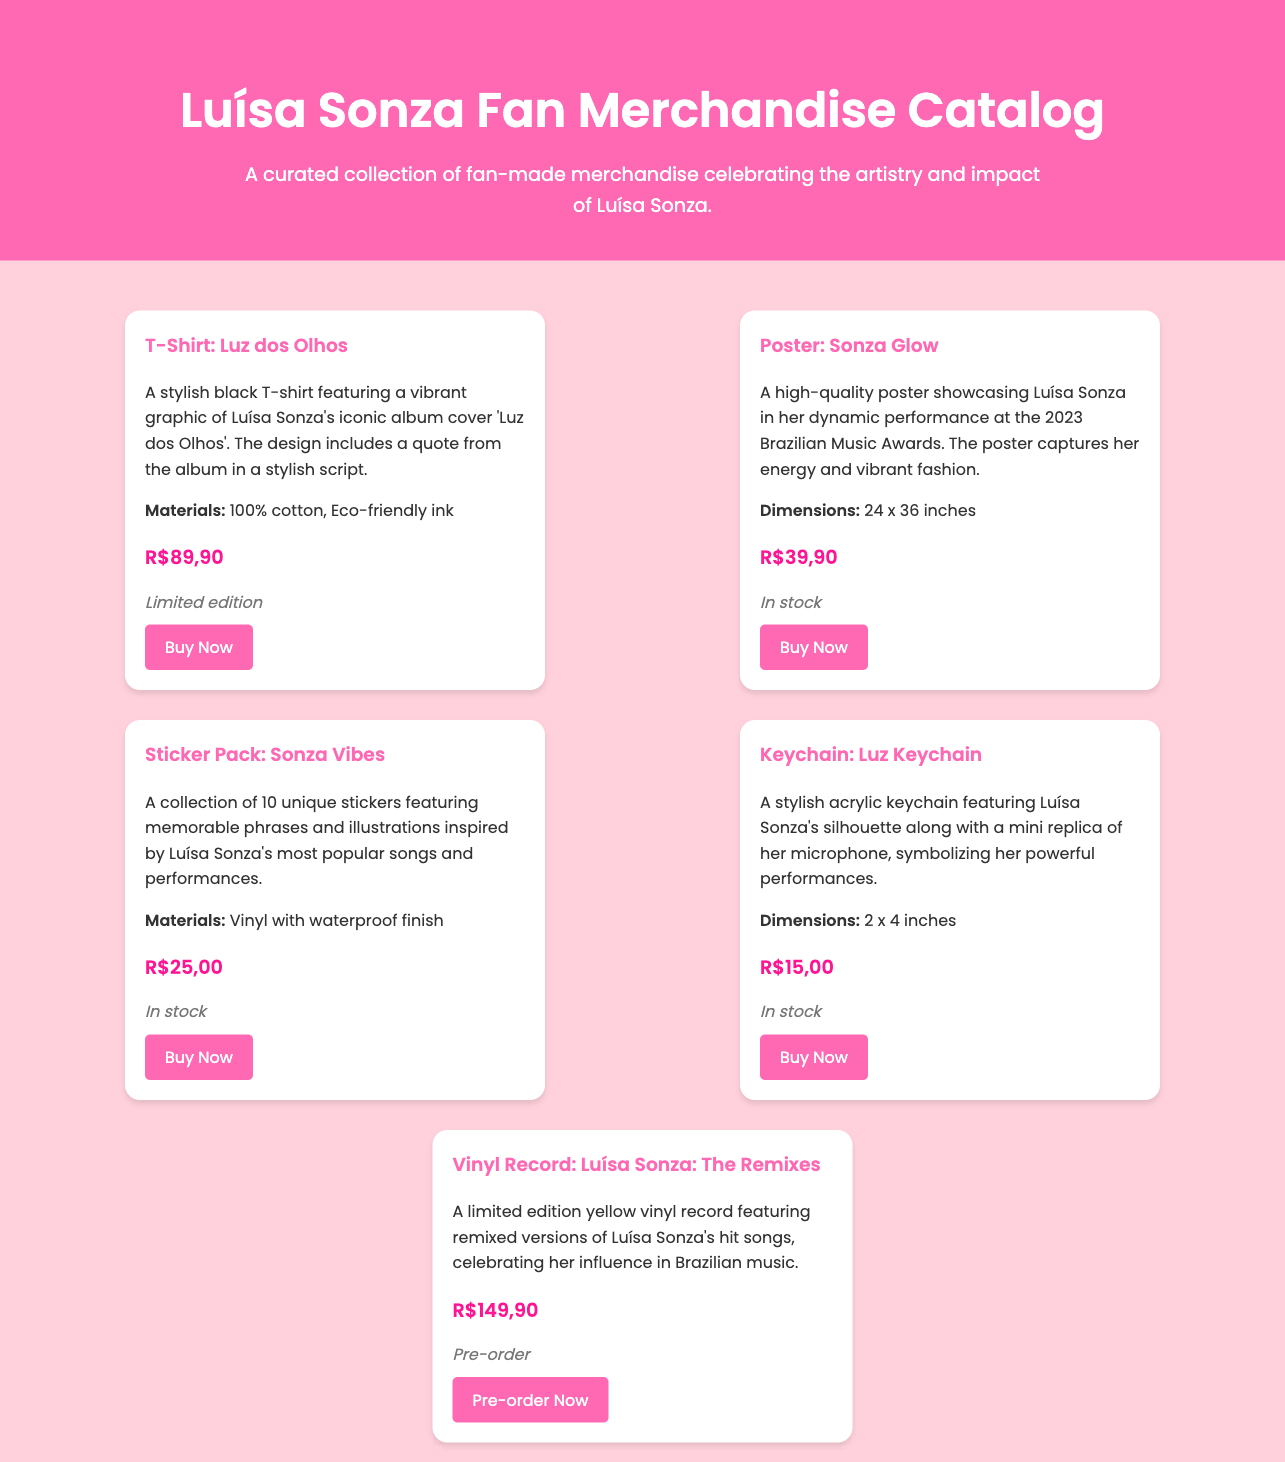What is the price of the T-Shirt: Luz dos Olhos? The price is specifically listed under the item details for the T-Shirt: Luz dos Olhos.
Answer: R$89,90 What type of item is the Sonza Glow? This question refers to the merchandise category of the item listed in the catalog, which is a poster.
Answer: Poster How many stickers are included in the Sonza Vibes pack? The information about the number of stickers is provided in the description of the Sticker Pack: Sonza Vibes.
Answer: 10 What is the availability status of the Vinyl Record: Luísa Sonza: The Remixes? The availability status is given in the item details for the vinyl record.
Answer: Pre-order What are the dimensions of the Keychain: Luz Keychain? The dimensions of the keychain are specified in the item description for the Keychain: Luz Keychain.
Answer: 2 x 4 inches Which item has the lowest price? By comparing the prices listed for each item, the answer can be identified.
Answer: R$15,00 What material is used for the T-Shirt: Luz dos Olhos? The materials are listed in the details of the T-Shirt: Luz dos Olhos.
Answer: 100% cotton, Eco-friendly ink Name the item that showcases Luísa Sonza's performance at the 2023 Brazilian Music Awards. This request requires recognition of the item description mentioning the event.
Answer: Poster: Sonza Glow What color is the limited edition vinyl record? The color of the vinyl record is explicitly mentioned in its description.
Answer: Yellow 